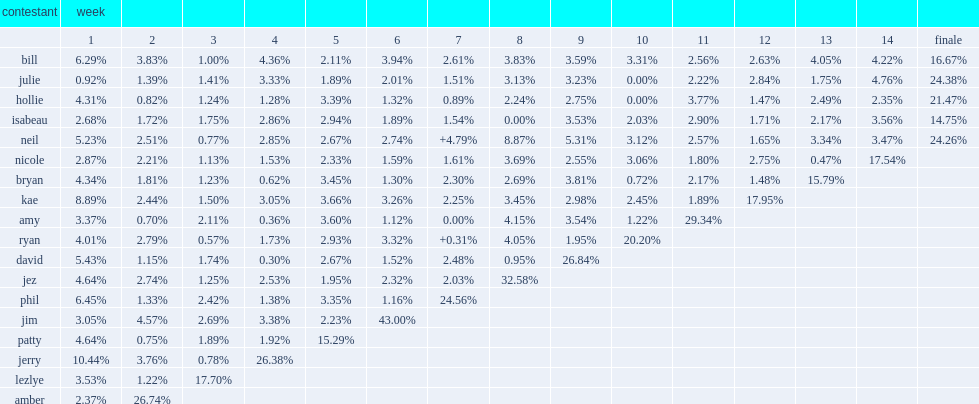In week 12, who was the biggest loser with a percentage weight loss of 2.84%? Julie. 